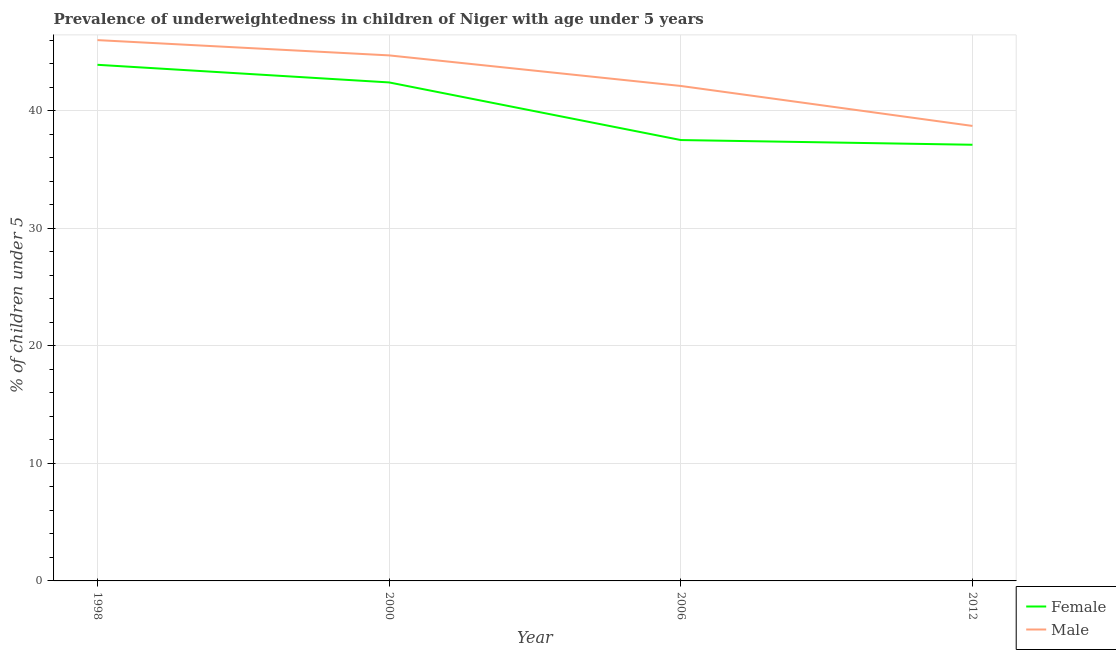How many different coloured lines are there?
Your answer should be very brief. 2. Does the line corresponding to percentage of underweighted female children intersect with the line corresponding to percentage of underweighted male children?
Keep it short and to the point. No. What is the percentage of underweighted female children in 2000?
Keep it short and to the point. 42.4. Across all years, what is the maximum percentage of underweighted female children?
Ensure brevity in your answer.  43.9. Across all years, what is the minimum percentage of underweighted female children?
Your response must be concise. 37.1. In which year was the percentage of underweighted male children maximum?
Provide a succinct answer. 1998. In which year was the percentage of underweighted female children minimum?
Ensure brevity in your answer.  2012. What is the total percentage of underweighted female children in the graph?
Provide a short and direct response. 160.9. What is the difference between the percentage of underweighted male children in 2012 and the percentage of underweighted female children in 1998?
Offer a very short reply. -5.2. What is the average percentage of underweighted female children per year?
Your answer should be very brief. 40.23. In the year 1998, what is the difference between the percentage of underweighted female children and percentage of underweighted male children?
Offer a very short reply. -2.1. What is the ratio of the percentage of underweighted male children in 2000 to that in 2006?
Your response must be concise. 1.06. Is the percentage of underweighted male children in 1998 less than that in 2000?
Your answer should be compact. No. Is the difference between the percentage of underweighted male children in 2000 and 2012 greater than the difference between the percentage of underweighted female children in 2000 and 2012?
Provide a succinct answer. Yes. What is the difference between the highest and the second highest percentage of underweighted female children?
Your answer should be compact. 1.5. What is the difference between the highest and the lowest percentage of underweighted male children?
Give a very brief answer. 7.3. Is the sum of the percentage of underweighted female children in 2000 and 2006 greater than the maximum percentage of underweighted male children across all years?
Your answer should be very brief. Yes. Is the percentage of underweighted female children strictly greater than the percentage of underweighted male children over the years?
Give a very brief answer. No. How many years are there in the graph?
Offer a terse response. 4. Does the graph contain any zero values?
Provide a short and direct response. No. Does the graph contain grids?
Make the answer very short. Yes. How many legend labels are there?
Your response must be concise. 2. What is the title of the graph?
Give a very brief answer. Prevalence of underweightedness in children of Niger with age under 5 years. What is the label or title of the Y-axis?
Offer a terse response.  % of children under 5. What is the  % of children under 5 of Female in 1998?
Your answer should be very brief. 43.9. What is the  % of children under 5 of Female in 2000?
Provide a succinct answer. 42.4. What is the  % of children under 5 in Male in 2000?
Keep it short and to the point. 44.7. What is the  % of children under 5 in Female in 2006?
Provide a succinct answer. 37.5. What is the  % of children under 5 in Male in 2006?
Provide a short and direct response. 42.1. What is the  % of children under 5 of Female in 2012?
Offer a very short reply. 37.1. What is the  % of children under 5 in Male in 2012?
Keep it short and to the point. 38.7. Across all years, what is the maximum  % of children under 5 in Female?
Ensure brevity in your answer.  43.9. Across all years, what is the maximum  % of children under 5 of Male?
Ensure brevity in your answer.  46. Across all years, what is the minimum  % of children under 5 of Female?
Offer a very short reply. 37.1. Across all years, what is the minimum  % of children under 5 in Male?
Make the answer very short. 38.7. What is the total  % of children under 5 of Female in the graph?
Ensure brevity in your answer.  160.9. What is the total  % of children under 5 of Male in the graph?
Ensure brevity in your answer.  171.5. What is the difference between the  % of children under 5 in Female in 1998 and that in 2000?
Ensure brevity in your answer.  1.5. What is the difference between the  % of children under 5 of Male in 1998 and that in 2000?
Your answer should be very brief. 1.3. What is the difference between the  % of children under 5 in Female in 2000 and that in 2006?
Your answer should be very brief. 4.9. What is the difference between the  % of children under 5 of Male in 2000 and that in 2012?
Ensure brevity in your answer.  6. What is the difference between the  % of children under 5 in Female in 2006 and that in 2012?
Offer a terse response. 0.4. What is the difference between the  % of children under 5 of Male in 2006 and that in 2012?
Your answer should be very brief. 3.4. What is the difference between the  % of children under 5 of Female in 1998 and the  % of children under 5 of Male in 2006?
Provide a short and direct response. 1.8. What is the difference between the  % of children under 5 in Female in 1998 and the  % of children under 5 in Male in 2012?
Your answer should be very brief. 5.2. What is the average  % of children under 5 of Female per year?
Provide a succinct answer. 40.23. What is the average  % of children under 5 of Male per year?
Your answer should be very brief. 42.88. In the year 1998, what is the difference between the  % of children under 5 of Female and  % of children under 5 of Male?
Provide a short and direct response. -2.1. In the year 2000, what is the difference between the  % of children under 5 of Female and  % of children under 5 of Male?
Your answer should be compact. -2.3. In the year 2012, what is the difference between the  % of children under 5 in Female and  % of children under 5 in Male?
Offer a terse response. -1.6. What is the ratio of the  % of children under 5 of Female in 1998 to that in 2000?
Make the answer very short. 1.04. What is the ratio of the  % of children under 5 in Male in 1998 to that in 2000?
Ensure brevity in your answer.  1.03. What is the ratio of the  % of children under 5 in Female in 1998 to that in 2006?
Keep it short and to the point. 1.17. What is the ratio of the  % of children under 5 in Male in 1998 to that in 2006?
Provide a short and direct response. 1.09. What is the ratio of the  % of children under 5 in Female in 1998 to that in 2012?
Provide a succinct answer. 1.18. What is the ratio of the  % of children under 5 of Male in 1998 to that in 2012?
Your response must be concise. 1.19. What is the ratio of the  % of children under 5 in Female in 2000 to that in 2006?
Your answer should be very brief. 1.13. What is the ratio of the  % of children under 5 in Male in 2000 to that in 2006?
Provide a succinct answer. 1.06. What is the ratio of the  % of children under 5 of Female in 2000 to that in 2012?
Your answer should be very brief. 1.14. What is the ratio of the  % of children under 5 of Male in 2000 to that in 2012?
Make the answer very short. 1.16. What is the ratio of the  % of children under 5 of Female in 2006 to that in 2012?
Your answer should be compact. 1.01. What is the ratio of the  % of children under 5 of Male in 2006 to that in 2012?
Provide a short and direct response. 1.09. What is the difference between the highest and the second highest  % of children under 5 in Male?
Provide a short and direct response. 1.3. What is the difference between the highest and the lowest  % of children under 5 of Female?
Offer a very short reply. 6.8. 